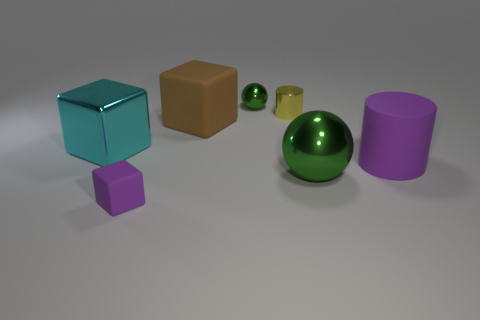What materials do the objects in the image appear to be made of? The objects in the image seem to have smooth and reflective surfaces, suggesting they are rendered to mimic materials like polished metal or plastic, which are often used in computer-generated imagery for their sleek and shiny appearance. 